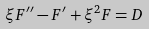Convert formula to latex. <formula><loc_0><loc_0><loc_500><loc_500>\xi F ^ { \prime \prime } - F ^ { \prime } + \xi ^ { 2 } F = D</formula> 